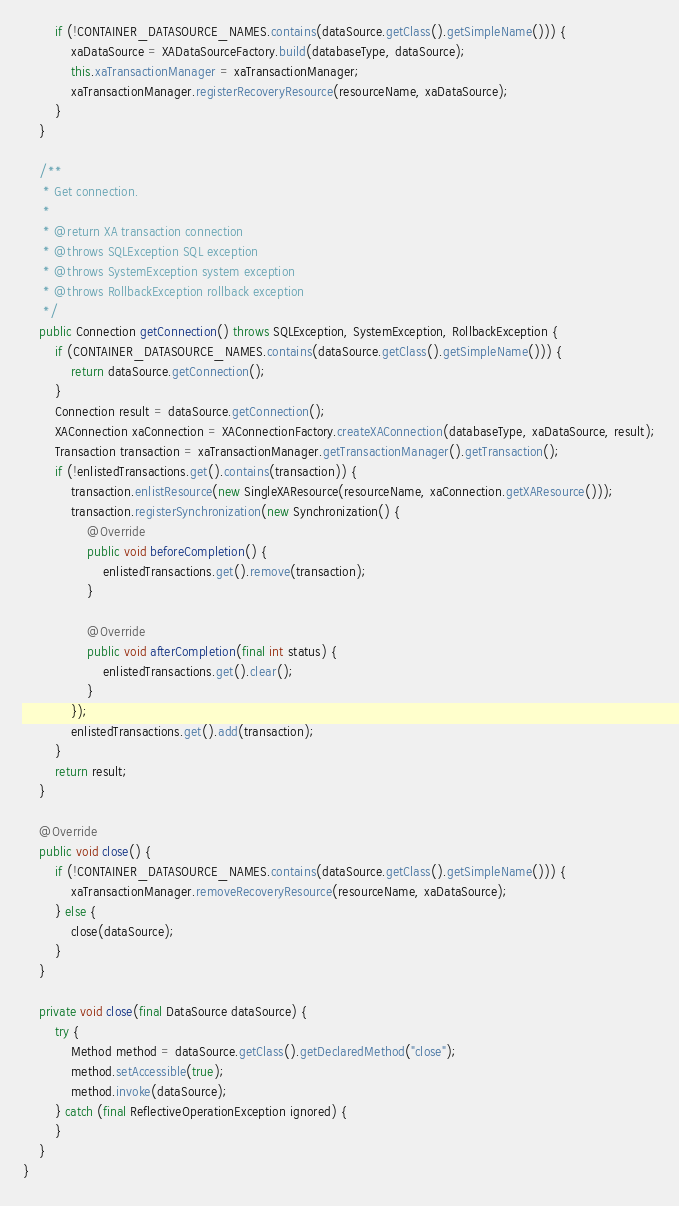Convert code to text. <code><loc_0><loc_0><loc_500><loc_500><_Java_>        if (!CONTAINER_DATASOURCE_NAMES.contains(dataSource.getClass().getSimpleName())) {
            xaDataSource = XADataSourceFactory.build(databaseType, dataSource);
            this.xaTransactionManager = xaTransactionManager;
            xaTransactionManager.registerRecoveryResource(resourceName, xaDataSource);
        }
    }
    
    /**
     * Get connection.
     *
     * @return XA transaction connection
     * @throws SQLException SQL exception
     * @throws SystemException system exception
     * @throws RollbackException rollback exception
     */
    public Connection getConnection() throws SQLException, SystemException, RollbackException {
        if (CONTAINER_DATASOURCE_NAMES.contains(dataSource.getClass().getSimpleName())) {
            return dataSource.getConnection();
        }
        Connection result = dataSource.getConnection();
        XAConnection xaConnection = XAConnectionFactory.createXAConnection(databaseType, xaDataSource, result);
        Transaction transaction = xaTransactionManager.getTransactionManager().getTransaction();
        if (!enlistedTransactions.get().contains(transaction)) {
            transaction.enlistResource(new SingleXAResource(resourceName, xaConnection.getXAResource()));
            transaction.registerSynchronization(new Synchronization() {
                @Override
                public void beforeCompletion() {
                    enlistedTransactions.get().remove(transaction);
                }
    
                @Override
                public void afterCompletion(final int status) {
                    enlistedTransactions.get().clear();
                }
            });
            enlistedTransactions.get().add(transaction);
        }
        return result;
    }
    
    @Override
    public void close() {
        if (!CONTAINER_DATASOURCE_NAMES.contains(dataSource.getClass().getSimpleName())) {
            xaTransactionManager.removeRecoveryResource(resourceName, xaDataSource);
        } else {
            close(dataSource);
        }
    }
    
    private void close(final DataSource dataSource) {
        try {
            Method method = dataSource.getClass().getDeclaredMethod("close");
            method.setAccessible(true);
            method.invoke(dataSource);
        } catch (final ReflectiveOperationException ignored) {
        }
    }
}
</code> 